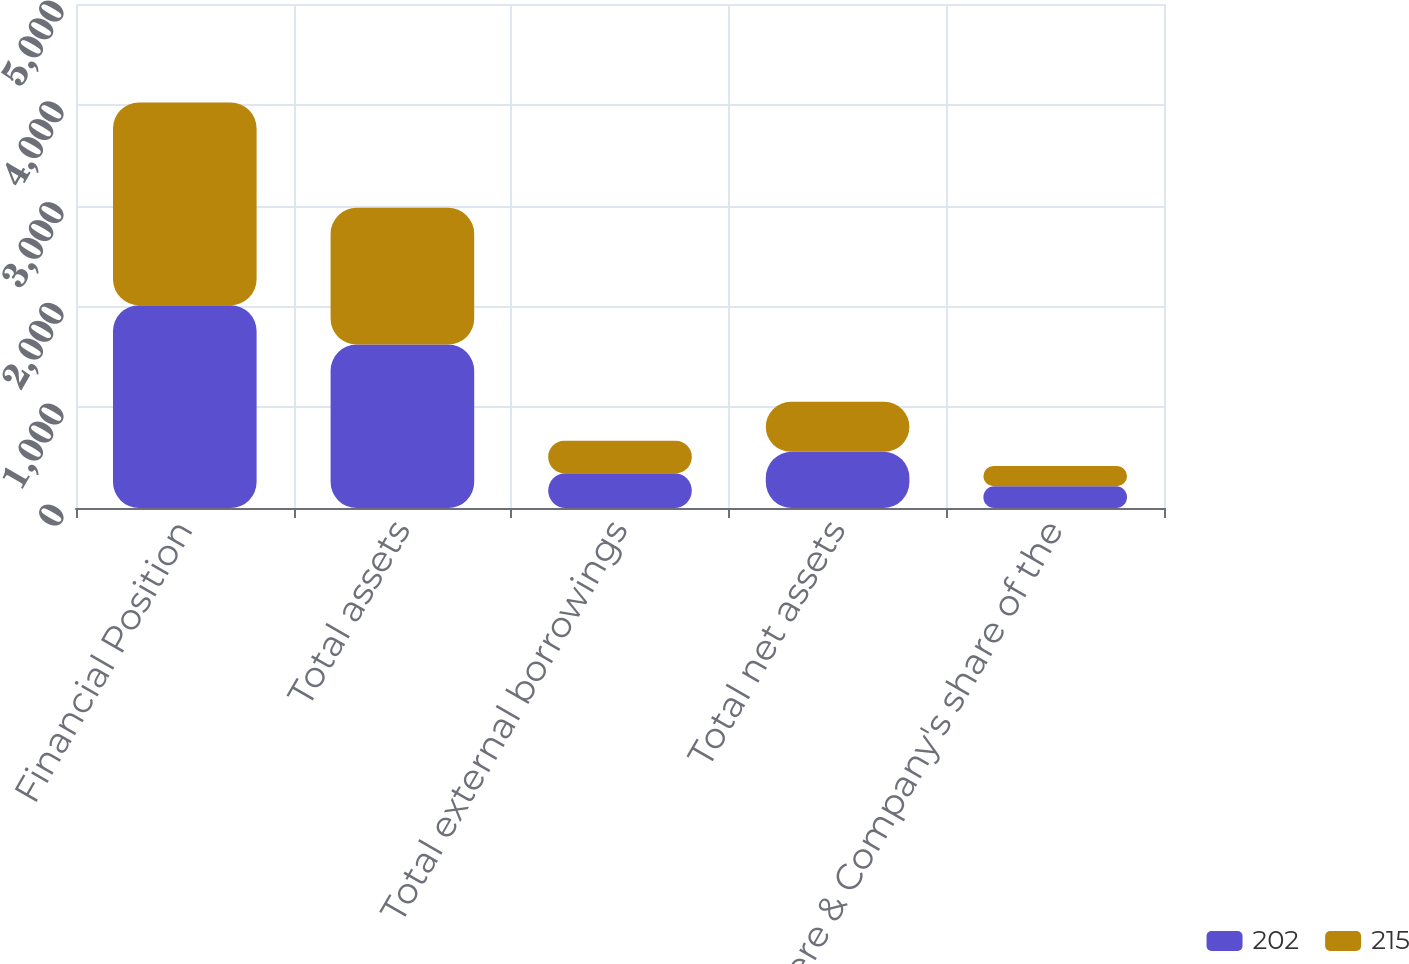Convert chart to OTSL. <chart><loc_0><loc_0><loc_500><loc_500><stacked_bar_chart><ecel><fcel>Financial Position<fcel>Total assets<fcel>Total external borrowings<fcel>Total net assets<fcel>Deere & Company's share of the<nl><fcel>202<fcel>2012<fcel>1621<fcel>345<fcel>558<fcel>215<nl><fcel>215<fcel>2011<fcel>1357<fcel>321<fcel>495<fcel>202<nl></chart> 